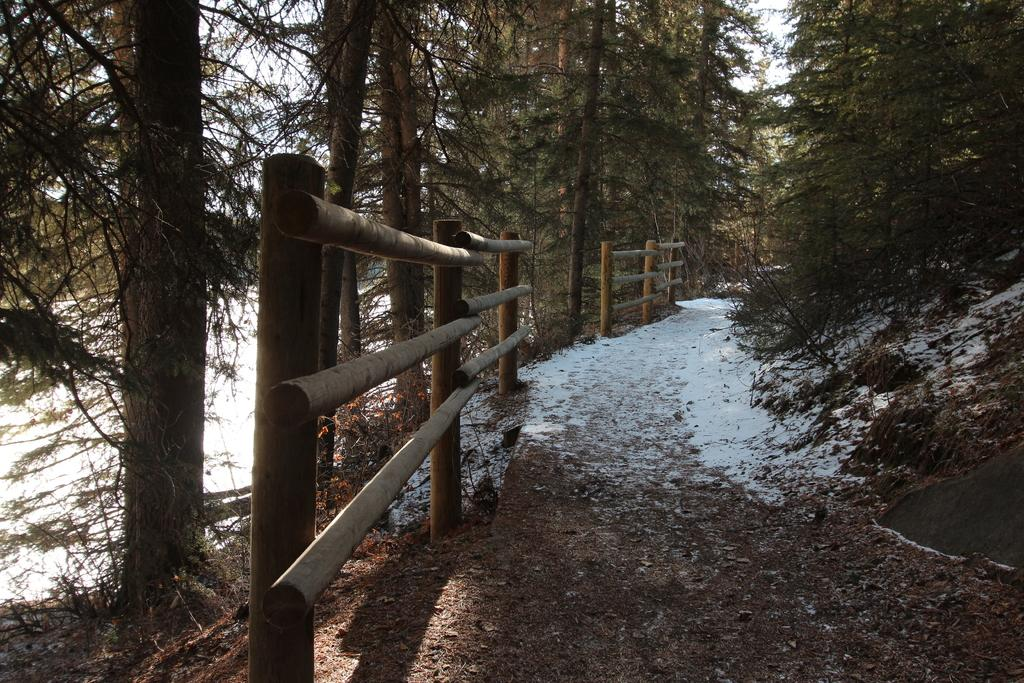What type of fencing is present on the path in the image? There is wooden fencing on the path in the image. What can be seen on both sides of the path in the image? There are trees on both the right and left sides of the path in the image. What is visible in the background of the image? The sky is visible in the background of the image. What type of trade is taking place in the image? There is no trade taking place in the image; it features a path with wooden fencing and trees on both sides. Can you see anyone skating in the image? There is no one skating in the image; it primarily focuses on the path, fencing, and trees. 